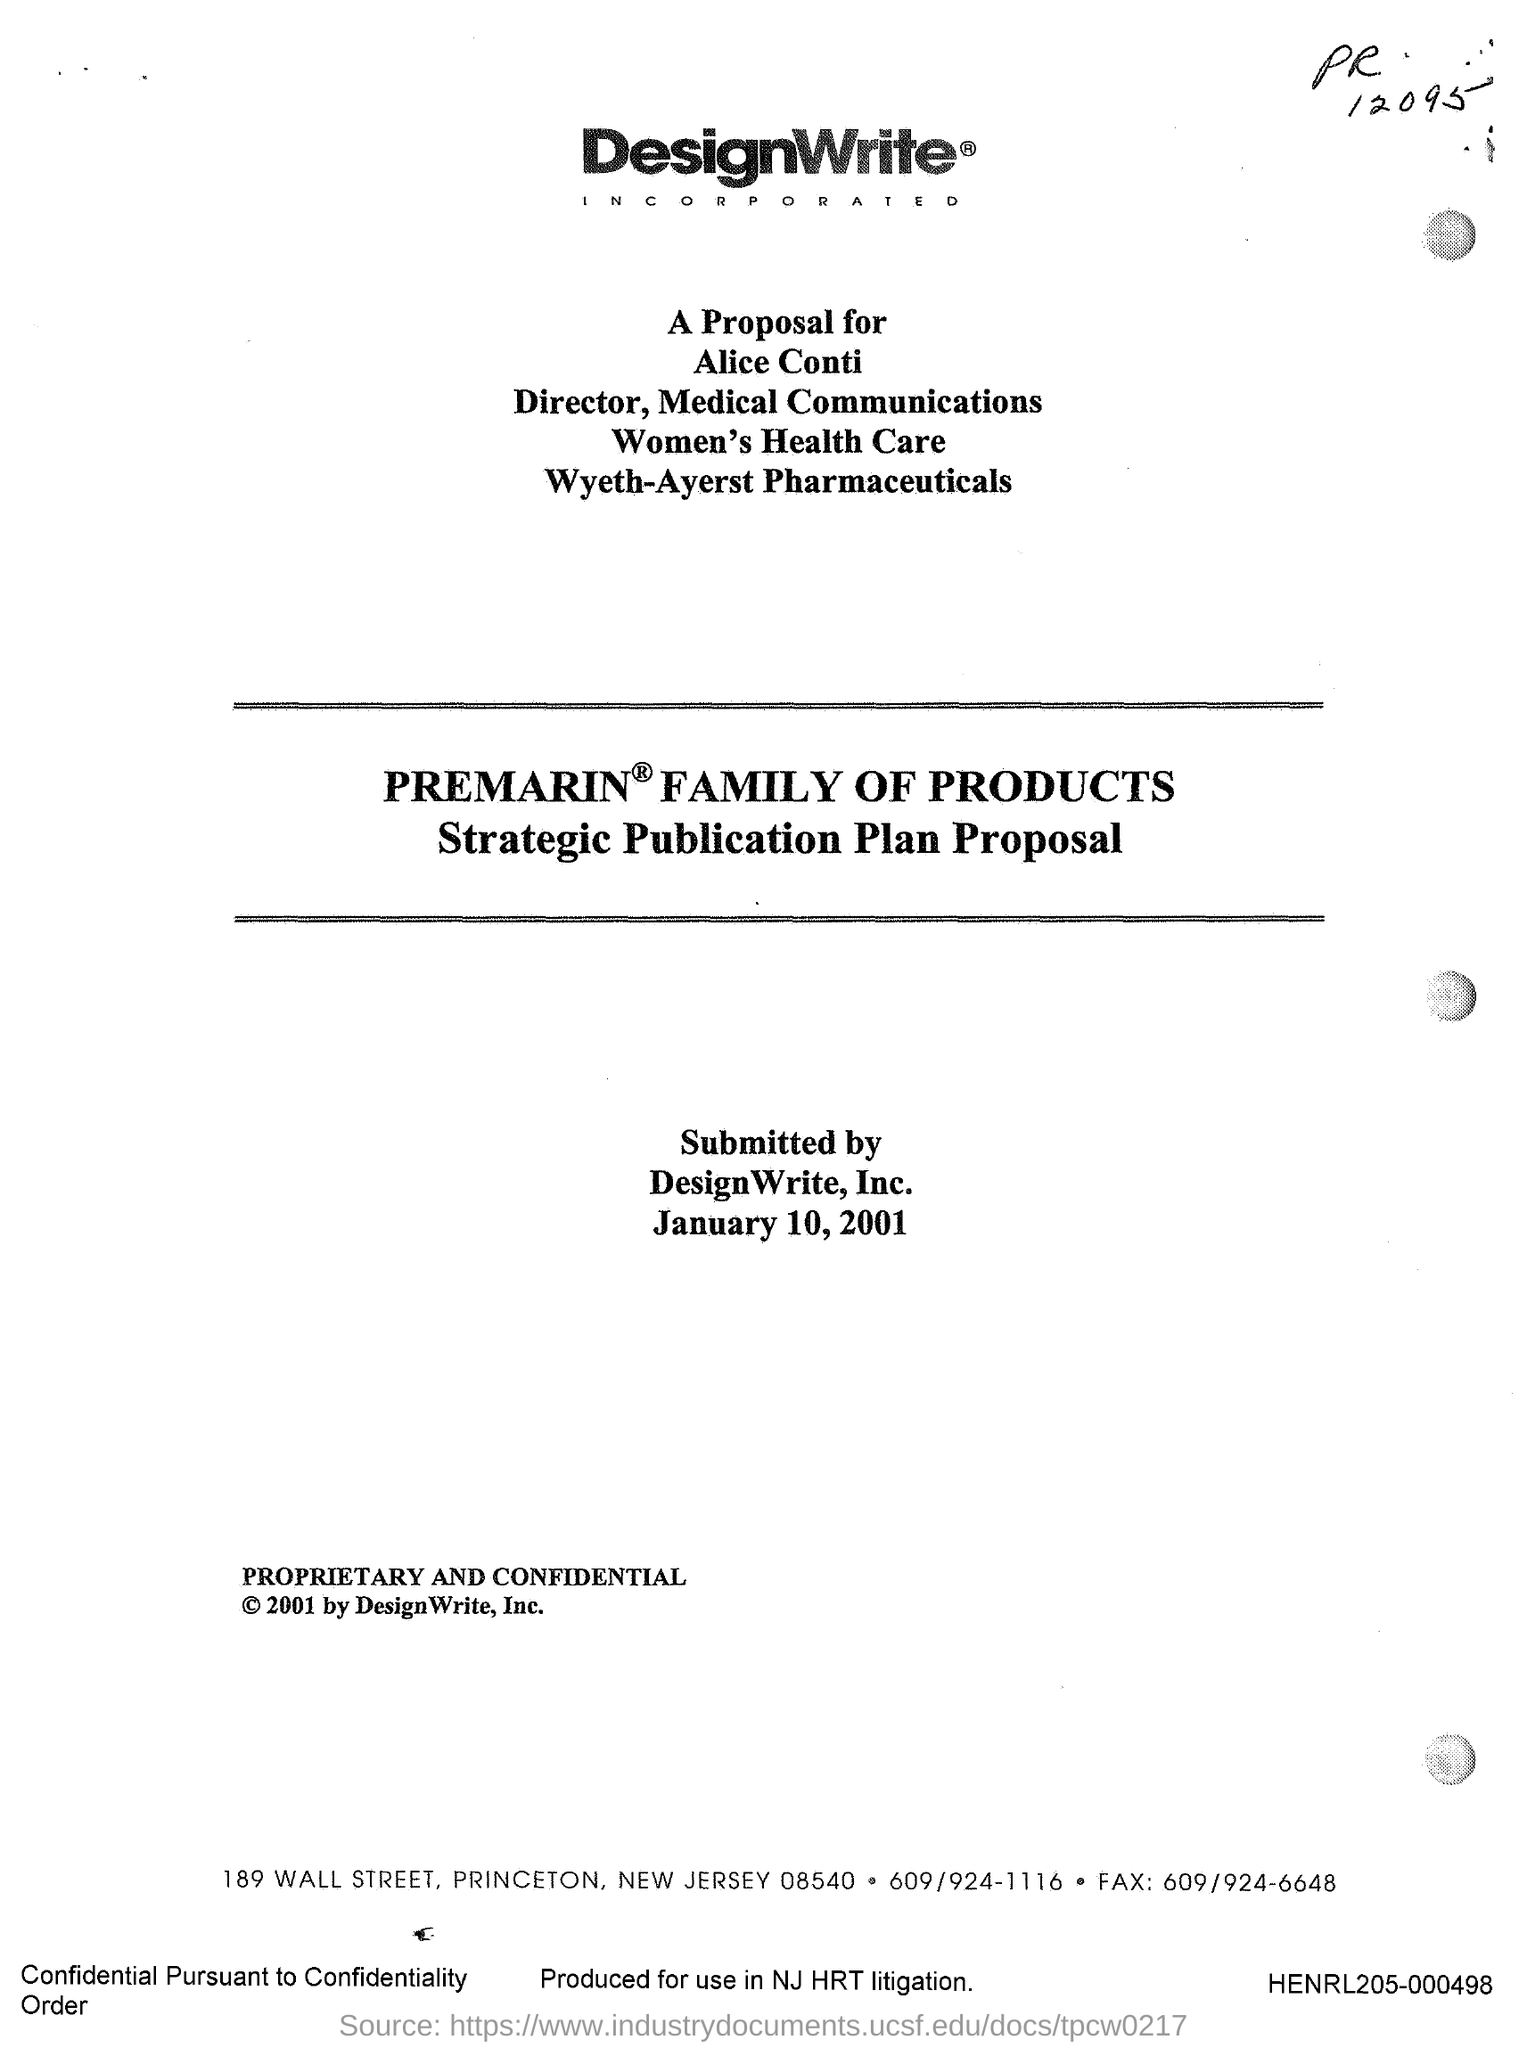When was it submitted?
Provide a succinct answer. January 10, 2001. Produced to use in what?
Give a very brief answer. NJ HRT litigation. What is the Document Number?
Your answer should be compact. HENRL205-000498. 